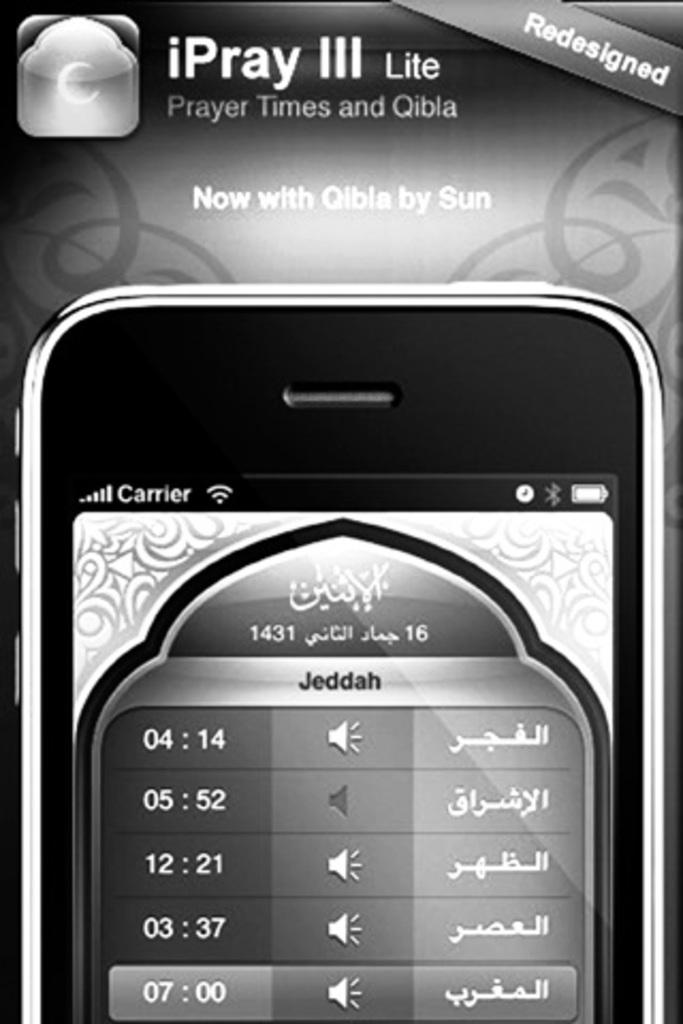<image>
Render a clear and concise summary of the photo. A picture of a cell phone that has a redesigned message on the front. 